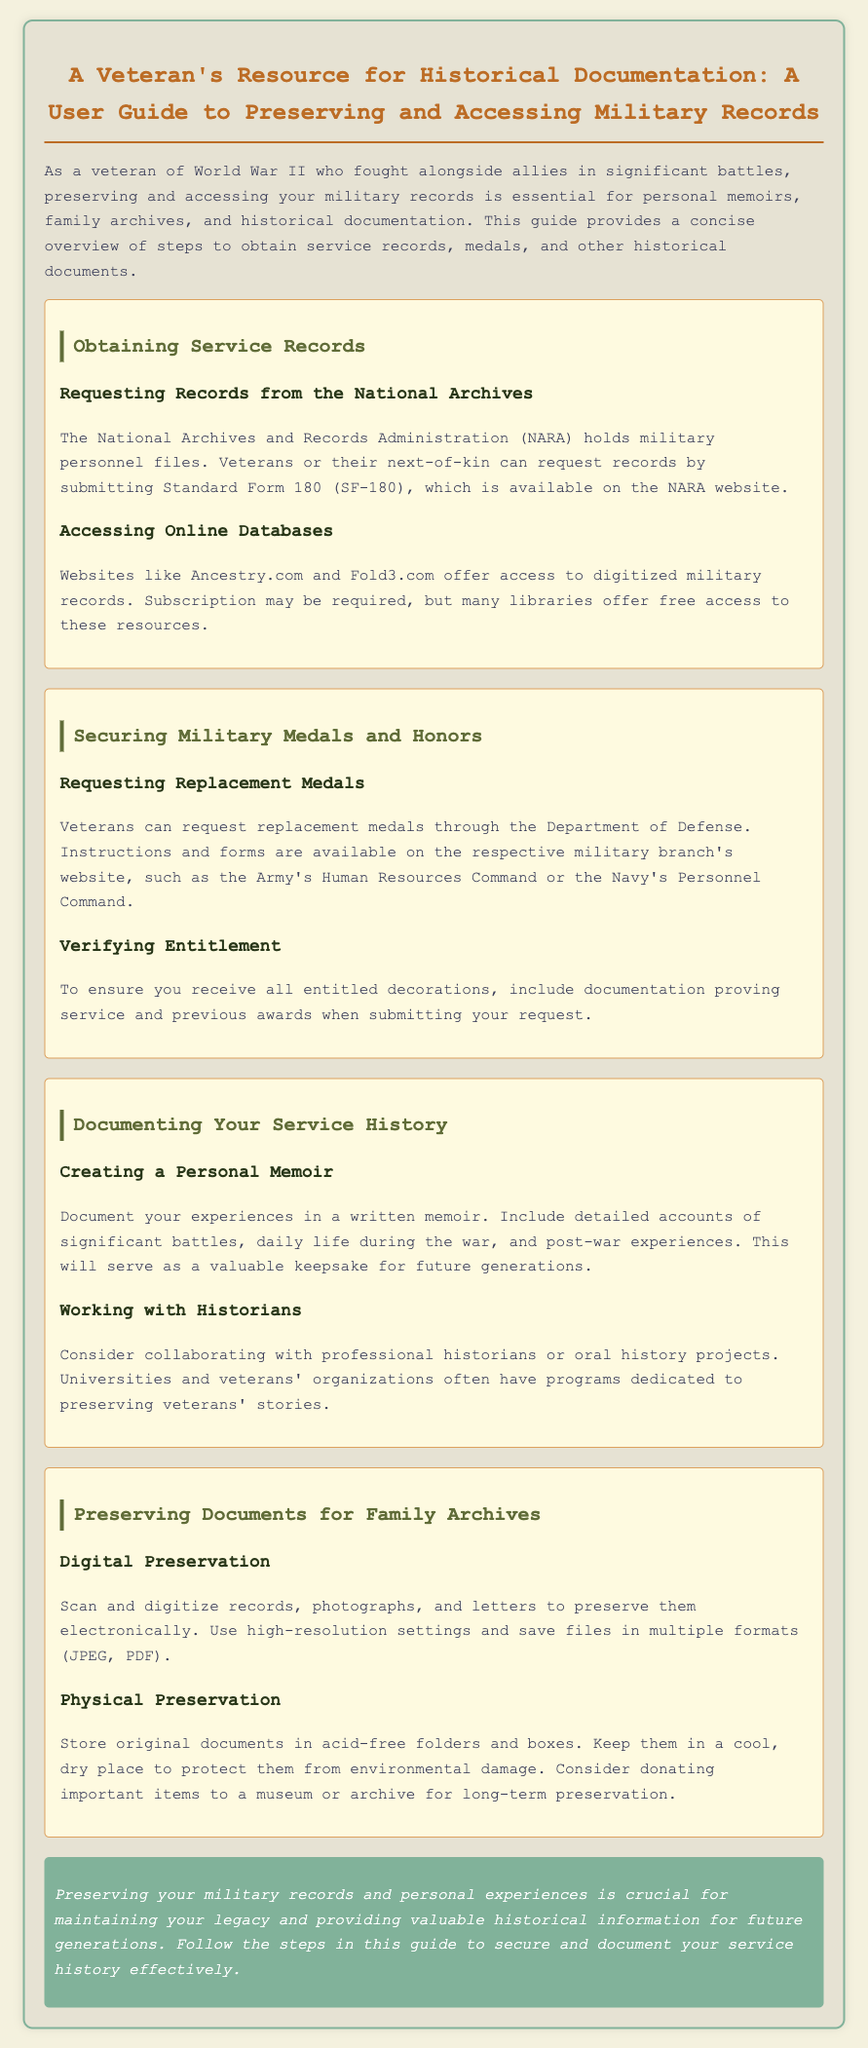What form is needed to request military records? The document specifies that Standard Form 180 (SF-180) is needed to request military records from NARA.
Answer: Standard Form 180 (SF-180) Which organization holds military personnel files? According to the document, the National Archives and Records Administration (NARA) holds military personnel files.
Answer: National Archives and Records Administration (NARA) What is one website mentioned for accessing digitized military records? The document lists Ancestry.com as one website for accessing digitized military records.
Answer: Ancestry.com What should be included when requesting replacement medals? The document states that documentation proving service and previous awards should be included to ensure all entitled decorations are received.
Answer: Documentation proving service and previous awards What is a suggested method for preserving original documents? The document recommends storing original documents in acid-free folders and boxes to protect them.
Answer: Acid-free folders and boxes Why is creating a personal memoir important? The document suggests that documenting experiences serves as a valuable keepsake for future generations.
Answer: Valuable keepsake for future generations How can veterans collaborate to preserve their stories? Veterans can work with historians or oral history projects as per the document's guidance.
Answer: Historians or oral history projects What is a digital preservation method mentioned in the guide? The guide mentions scanning and digitizing records as a method for digital preservation.
Answer: Scanning and digitizing records What is a good practice for storing documents? The document emphasizes keeping documents in a cool, dry place to protect them from environmental damage.
Answer: Cool, dry place 